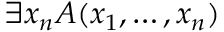<formula> <loc_0><loc_0><loc_500><loc_500>\exists x _ { n } A ( x _ { 1 } , \dots , x _ { n } )</formula> 